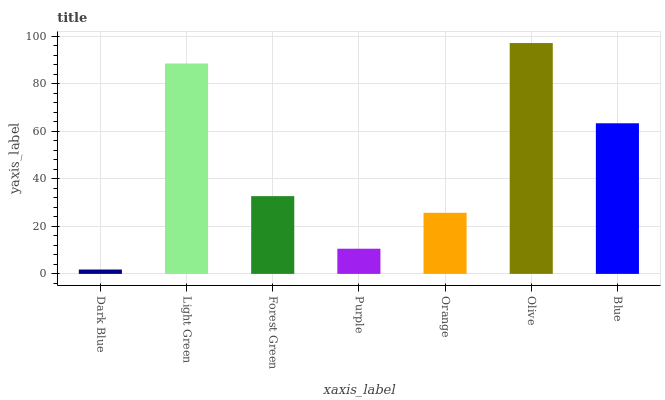Is Light Green the minimum?
Answer yes or no. No. Is Light Green the maximum?
Answer yes or no. No. Is Light Green greater than Dark Blue?
Answer yes or no. Yes. Is Dark Blue less than Light Green?
Answer yes or no. Yes. Is Dark Blue greater than Light Green?
Answer yes or no. No. Is Light Green less than Dark Blue?
Answer yes or no. No. Is Forest Green the high median?
Answer yes or no. Yes. Is Forest Green the low median?
Answer yes or no. Yes. Is Olive the high median?
Answer yes or no. No. Is Orange the low median?
Answer yes or no. No. 